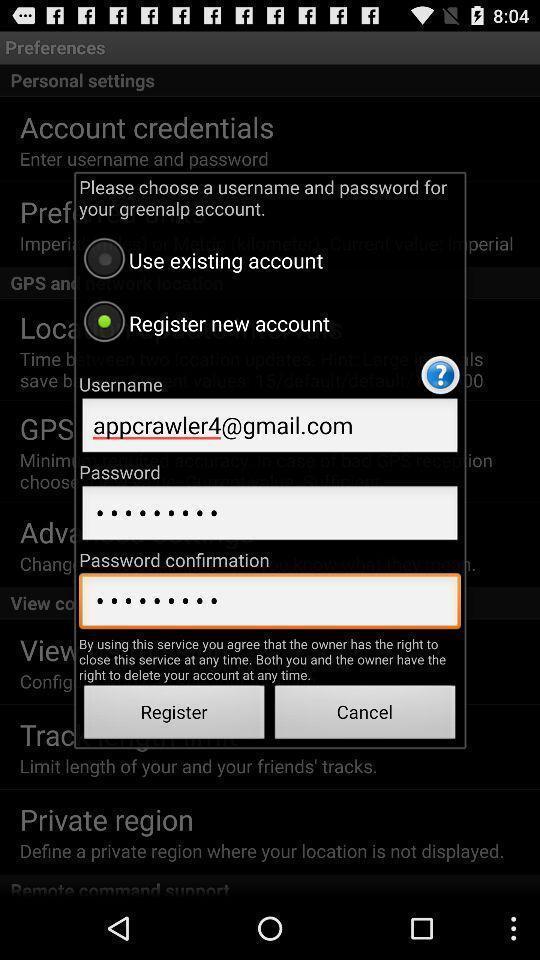Describe the visual elements of this screenshot. Pop-up window showing registration page for an account. 